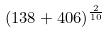<formula> <loc_0><loc_0><loc_500><loc_500>( 1 3 8 + 4 0 6 ) ^ { \frac { 2 } { 1 0 } }</formula> 